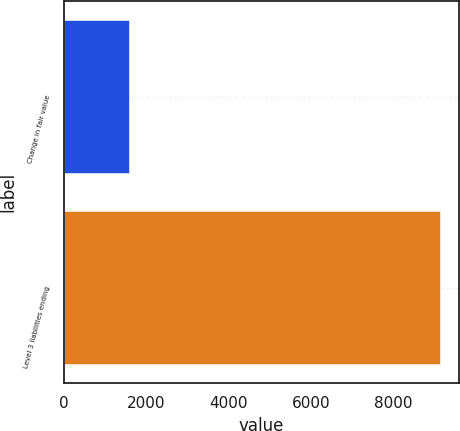<chart> <loc_0><loc_0><loc_500><loc_500><bar_chart><fcel>Change in fair value<fcel>Level 3 liabilities ending<nl><fcel>1590<fcel>9153<nl></chart> 